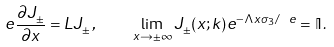Convert formula to latex. <formula><loc_0><loc_0><loc_500><loc_500>\ e \frac { \partial { J } _ { \pm } } { \partial x } = { L } { J } _ { \pm } \, , \quad \lim _ { x \rightarrow \pm \infty } { J } _ { \pm } ( x ; k ) e ^ { - \Lambda x \sigma _ { 3 } / \ e } = \mathbb { I } \, .</formula> 